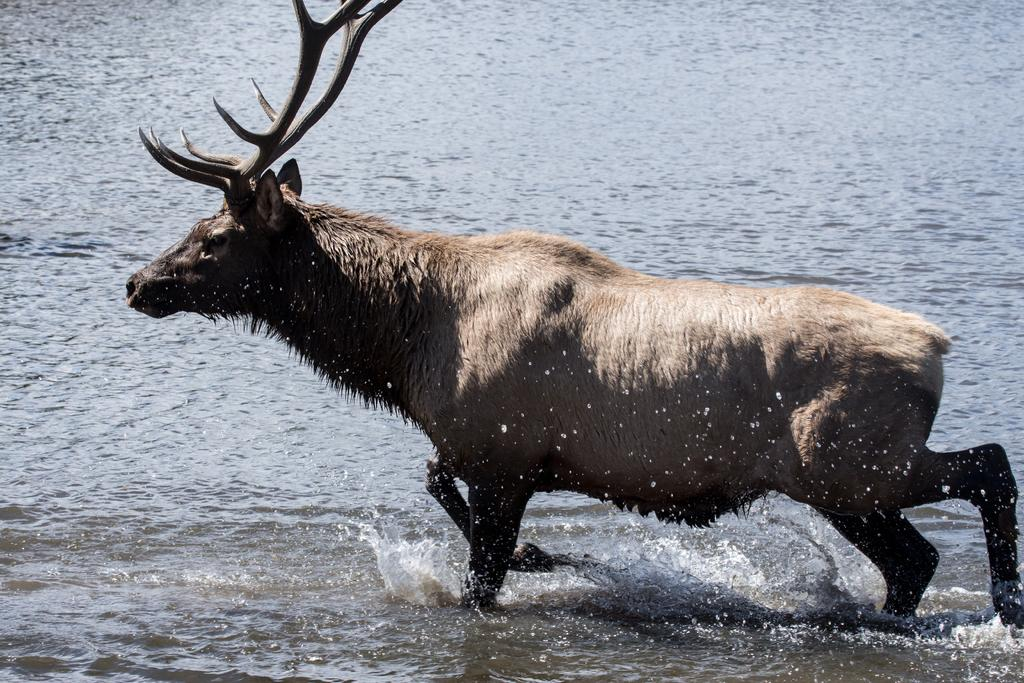What is present in the image? There is water visible in the image, and there is an elk in the image. Can you describe the elk in the image? The elk is a large mammal with antlers and a brown coat. What is the primary setting of the image? The primary setting of the image is water, as it is the main element visible. Where is the crate located in the image? There is no crate present in the image. What type of key is the elk holding in the image? The elk is not holding any key in the image. 